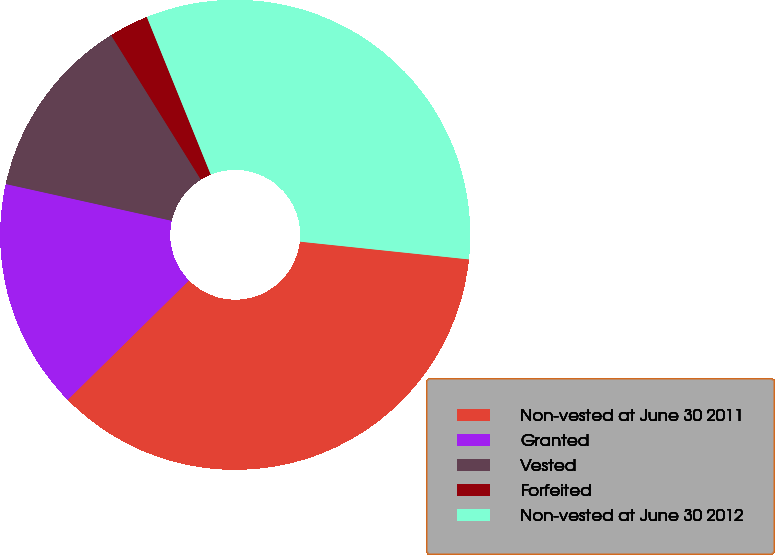Convert chart. <chart><loc_0><loc_0><loc_500><loc_500><pie_chart><fcel>Non-vested at June 30 2011<fcel>Granted<fcel>Vested<fcel>Forfeited<fcel>Non-vested at June 30 2012<nl><fcel>35.96%<fcel>15.85%<fcel>12.68%<fcel>2.72%<fcel>32.8%<nl></chart> 